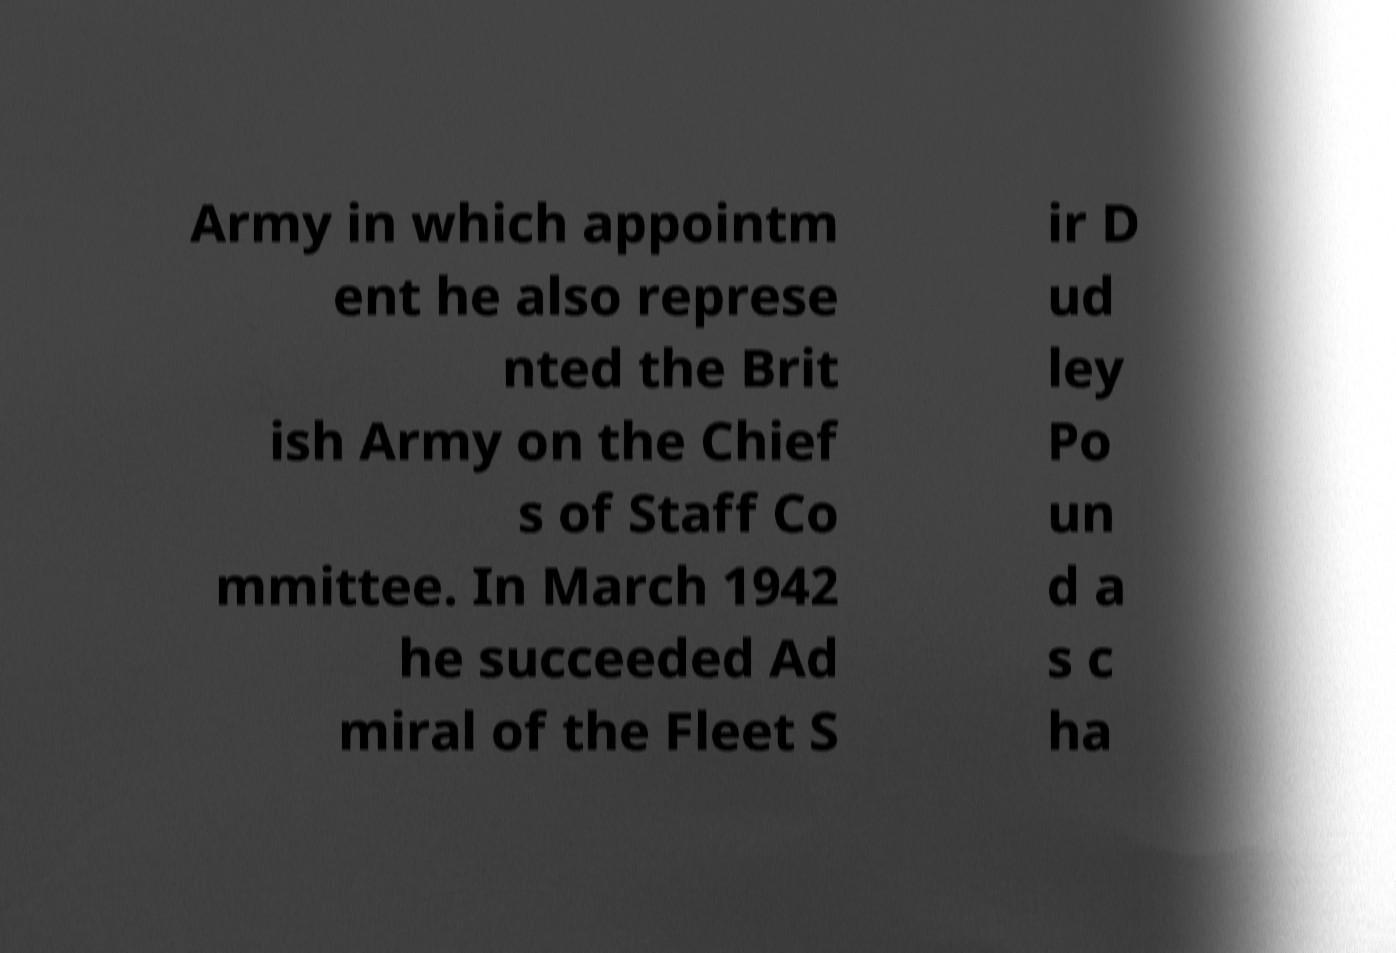What messages or text are displayed in this image? I need them in a readable, typed format. Army in which appointm ent he also represe nted the Brit ish Army on the Chief s of Staff Co mmittee. In March 1942 he succeeded Ad miral of the Fleet S ir D ud ley Po un d a s c ha 